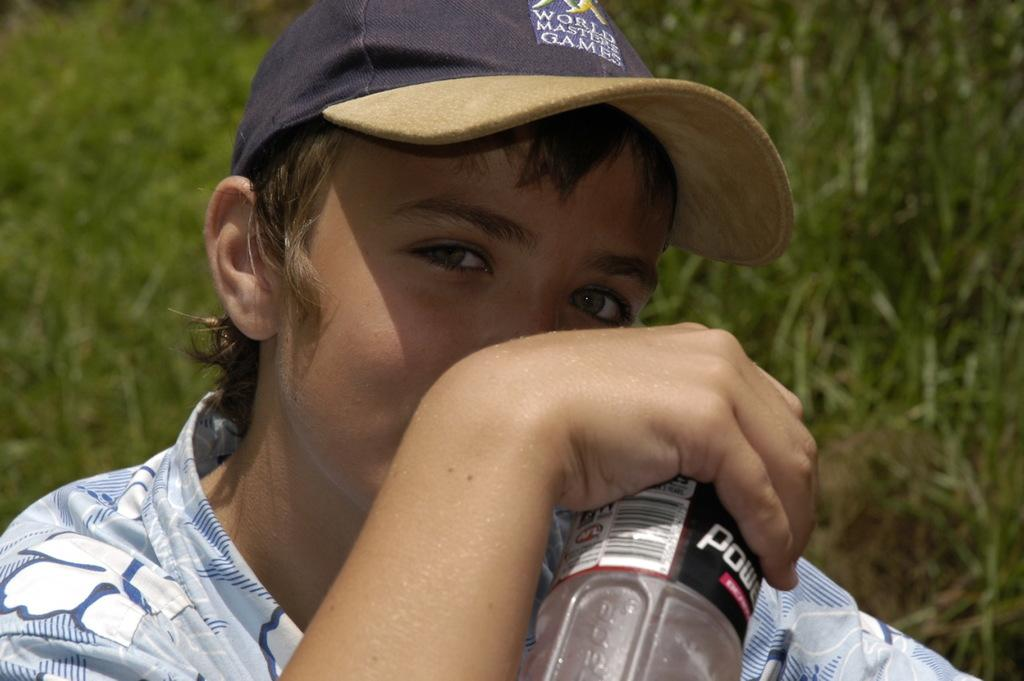What is the main subject of the image? There is a person in the image. What is the person holding in the image? The person is holding a bottle with his hand. Can you describe the person's attire in the image? The person is wearing a cap. What can be seen in the background of the image? There is grass in the background of the image. What is the person's belief about friction in the image? There is no information about the person's beliefs or friction in the image. 